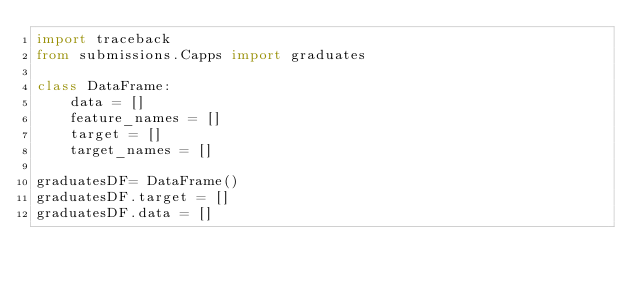Convert code to text. <code><loc_0><loc_0><loc_500><loc_500><_Python_>import traceback
from submissions.Capps import graduates

class DataFrame:
    data = []
    feature_names = []
    target = []
    target_names = []

graduatesDF= DataFrame()
graduatesDF.target = []
graduatesDF.data = []

</code> 